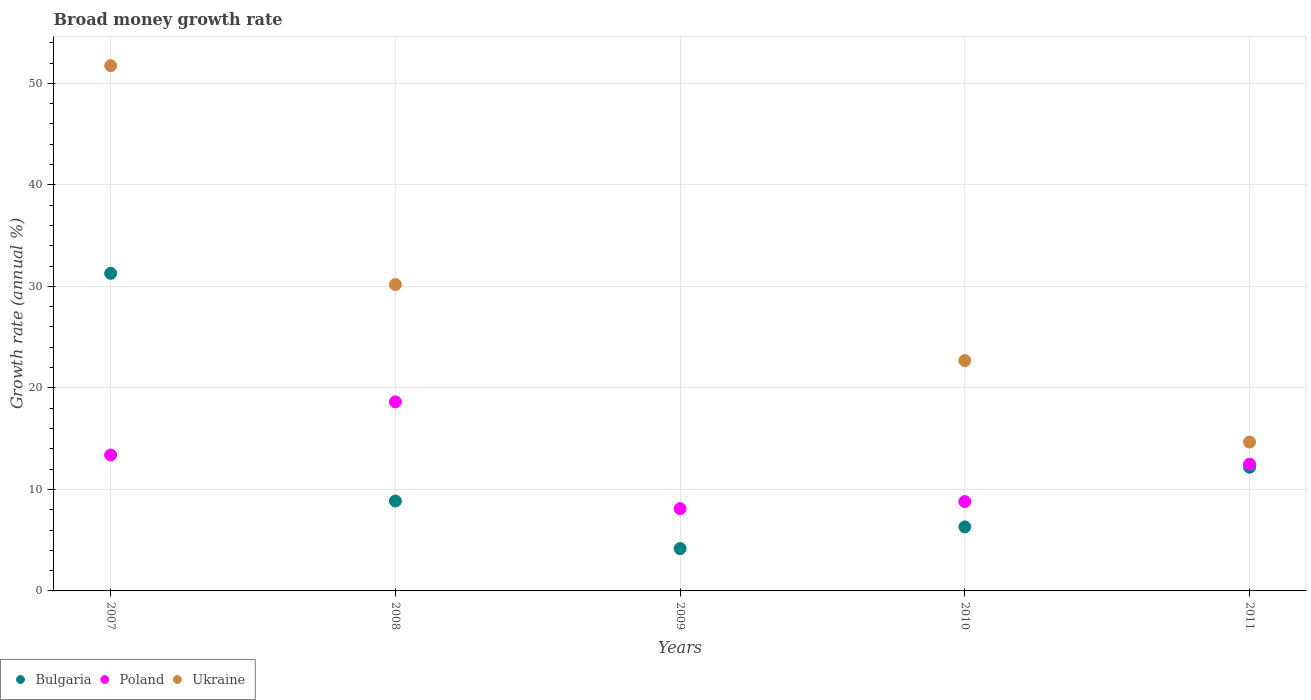How many different coloured dotlines are there?
Make the answer very short. 3. Is the number of dotlines equal to the number of legend labels?
Ensure brevity in your answer.  No. What is the growth rate in Ukraine in 2009?
Your response must be concise. 0. Across all years, what is the maximum growth rate in Bulgaria?
Offer a very short reply. 31.29. Across all years, what is the minimum growth rate in Ukraine?
Your answer should be compact. 0. What is the total growth rate in Bulgaria in the graph?
Your response must be concise. 62.8. What is the difference between the growth rate in Poland in 2009 and that in 2011?
Ensure brevity in your answer.  -4.38. What is the difference between the growth rate in Ukraine in 2010 and the growth rate in Poland in 2009?
Your response must be concise. 14.59. What is the average growth rate in Poland per year?
Provide a succinct answer. 12.28. In the year 2007, what is the difference between the growth rate in Ukraine and growth rate in Bulgaria?
Your answer should be very brief. 20.46. What is the ratio of the growth rate in Bulgaria in 2008 to that in 2009?
Provide a succinct answer. 2.12. What is the difference between the highest and the second highest growth rate in Ukraine?
Keep it short and to the point. 21.56. What is the difference between the highest and the lowest growth rate in Poland?
Give a very brief answer. 10.52. Is the sum of the growth rate in Poland in 2008 and 2011 greater than the maximum growth rate in Ukraine across all years?
Ensure brevity in your answer.  No. Is it the case that in every year, the sum of the growth rate in Poland and growth rate in Ukraine  is greater than the growth rate in Bulgaria?
Provide a short and direct response. Yes. Is the growth rate in Poland strictly less than the growth rate in Bulgaria over the years?
Provide a short and direct response. No. How many dotlines are there?
Offer a very short reply. 3. How many years are there in the graph?
Make the answer very short. 5. Does the graph contain any zero values?
Your response must be concise. Yes. Does the graph contain grids?
Offer a terse response. Yes. Where does the legend appear in the graph?
Offer a terse response. Bottom left. How many legend labels are there?
Your response must be concise. 3. What is the title of the graph?
Offer a very short reply. Broad money growth rate. Does "Benin" appear as one of the legend labels in the graph?
Ensure brevity in your answer.  No. What is the label or title of the X-axis?
Offer a very short reply. Years. What is the label or title of the Y-axis?
Provide a succinct answer. Growth rate (annual %). What is the Growth rate (annual %) of Bulgaria in 2007?
Offer a very short reply. 31.29. What is the Growth rate (annual %) in Poland in 2007?
Give a very brief answer. 13.39. What is the Growth rate (annual %) in Ukraine in 2007?
Offer a terse response. 51.75. What is the Growth rate (annual %) in Bulgaria in 2008?
Provide a short and direct response. 8.86. What is the Growth rate (annual %) in Poland in 2008?
Make the answer very short. 18.63. What is the Growth rate (annual %) in Ukraine in 2008?
Give a very brief answer. 30.18. What is the Growth rate (annual %) of Bulgaria in 2009?
Provide a succinct answer. 4.17. What is the Growth rate (annual %) in Poland in 2009?
Ensure brevity in your answer.  8.11. What is the Growth rate (annual %) in Ukraine in 2009?
Give a very brief answer. 0. What is the Growth rate (annual %) of Bulgaria in 2010?
Give a very brief answer. 6.3. What is the Growth rate (annual %) in Poland in 2010?
Give a very brief answer. 8.81. What is the Growth rate (annual %) of Ukraine in 2010?
Keep it short and to the point. 22.69. What is the Growth rate (annual %) in Bulgaria in 2011?
Offer a very short reply. 12.18. What is the Growth rate (annual %) of Poland in 2011?
Ensure brevity in your answer.  12.49. What is the Growth rate (annual %) of Ukraine in 2011?
Keep it short and to the point. 14.66. Across all years, what is the maximum Growth rate (annual %) in Bulgaria?
Offer a terse response. 31.29. Across all years, what is the maximum Growth rate (annual %) in Poland?
Make the answer very short. 18.63. Across all years, what is the maximum Growth rate (annual %) of Ukraine?
Offer a very short reply. 51.75. Across all years, what is the minimum Growth rate (annual %) in Bulgaria?
Give a very brief answer. 4.17. Across all years, what is the minimum Growth rate (annual %) in Poland?
Offer a terse response. 8.11. What is the total Growth rate (annual %) of Bulgaria in the graph?
Offer a very short reply. 62.8. What is the total Growth rate (annual %) of Poland in the graph?
Provide a succinct answer. 61.41. What is the total Growth rate (annual %) of Ukraine in the graph?
Your answer should be compact. 119.28. What is the difference between the Growth rate (annual %) in Bulgaria in 2007 and that in 2008?
Offer a very short reply. 22.43. What is the difference between the Growth rate (annual %) of Poland in 2007 and that in 2008?
Your answer should be compact. -5.24. What is the difference between the Growth rate (annual %) in Ukraine in 2007 and that in 2008?
Your answer should be very brief. 21.56. What is the difference between the Growth rate (annual %) of Bulgaria in 2007 and that in 2009?
Your answer should be compact. 27.11. What is the difference between the Growth rate (annual %) in Poland in 2007 and that in 2009?
Offer a very short reply. 5.28. What is the difference between the Growth rate (annual %) of Bulgaria in 2007 and that in 2010?
Offer a very short reply. 24.98. What is the difference between the Growth rate (annual %) in Poland in 2007 and that in 2010?
Make the answer very short. 4.58. What is the difference between the Growth rate (annual %) of Ukraine in 2007 and that in 2010?
Make the answer very short. 29.06. What is the difference between the Growth rate (annual %) of Bulgaria in 2007 and that in 2011?
Provide a succinct answer. 19.1. What is the difference between the Growth rate (annual %) of Poland in 2007 and that in 2011?
Give a very brief answer. 0.9. What is the difference between the Growth rate (annual %) in Ukraine in 2007 and that in 2011?
Offer a very short reply. 37.09. What is the difference between the Growth rate (annual %) in Bulgaria in 2008 and that in 2009?
Make the answer very short. 4.68. What is the difference between the Growth rate (annual %) of Poland in 2008 and that in 2009?
Provide a short and direct response. 10.52. What is the difference between the Growth rate (annual %) in Bulgaria in 2008 and that in 2010?
Provide a short and direct response. 2.55. What is the difference between the Growth rate (annual %) in Poland in 2008 and that in 2010?
Your response must be concise. 9.82. What is the difference between the Growth rate (annual %) in Ukraine in 2008 and that in 2010?
Keep it short and to the point. 7.49. What is the difference between the Growth rate (annual %) in Bulgaria in 2008 and that in 2011?
Your answer should be very brief. -3.32. What is the difference between the Growth rate (annual %) of Poland in 2008 and that in 2011?
Your response must be concise. 6.14. What is the difference between the Growth rate (annual %) in Ukraine in 2008 and that in 2011?
Give a very brief answer. 15.52. What is the difference between the Growth rate (annual %) of Bulgaria in 2009 and that in 2010?
Provide a short and direct response. -2.13. What is the difference between the Growth rate (annual %) in Poland in 2009 and that in 2010?
Your answer should be compact. -0.7. What is the difference between the Growth rate (annual %) of Bulgaria in 2009 and that in 2011?
Keep it short and to the point. -8.01. What is the difference between the Growth rate (annual %) of Poland in 2009 and that in 2011?
Your answer should be compact. -4.38. What is the difference between the Growth rate (annual %) of Bulgaria in 2010 and that in 2011?
Your answer should be very brief. -5.88. What is the difference between the Growth rate (annual %) of Poland in 2010 and that in 2011?
Keep it short and to the point. -3.68. What is the difference between the Growth rate (annual %) of Ukraine in 2010 and that in 2011?
Your answer should be very brief. 8.03. What is the difference between the Growth rate (annual %) in Bulgaria in 2007 and the Growth rate (annual %) in Poland in 2008?
Keep it short and to the point. 12.66. What is the difference between the Growth rate (annual %) of Bulgaria in 2007 and the Growth rate (annual %) of Ukraine in 2008?
Provide a short and direct response. 1.1. What is the difference between the Growth rate (annual %) of Poland in 2007 and the Growth rate (annual %) of Ukraine in 2008?
Your answer should be very brief. -16.79. What is the difference between the Growth rate (annual %) of Bulgaria in 2007 and the Growth rate (annual %) of Poland in 2009?
Provide a succinct answer. 23.18. What is the difference between the Growth rate (annual %) in Bulgaria in 2007 and the Growth rate (annual %) in Poland in 2010?
Your answer should be compact. 22.48. What is the difference between the Growth rate (annual %) of Bulgaria in 2007 and the Growth rate (annual %) of Ukraine in 2010?
Your response must be concise. 8.59. What is the difference between the Growth rate (annual %) of Poland in 2007 and the Growth rate (annual %) of Ukraine in 2010?
Provide a short and direct response. -9.3. What is the difference between the Growth rate (annual %) of Bulgaria in 2007 and the Growth rate (annual %) of Poland in 2011?
Provide a short and direct response. 18.8. What is the difference between the Growth rate (annual %) in Bulgaria in 2007 and the Growth rate (annual %) in Ukraine in 2011?
Your answer should be very brief. 16.63. What is the difference between the Growth rate (annual %) in Poland in 2007 and the Growth rate (annual %) in Ukraine in 2011?
Keep it short and to the point. -1.27. What is the difference between the Growth rate (annual %) in Bulgaria in 2008 and the Growth rate (annual %) in Poland in 2009?
Your answer should be very brief. 0.75. What is the difference between the Growth rate (annual %) in Bulgaria in 2008 and the Growth rate (annual %) in Poland in 2010?
Your answer should be compact. 0.05. What is the difference between the Growth rate (annual %) in Bulgaria in 2008 and the Growth rate (annual %) in Ukraine in 2010?
Your answer should be very brief. -13.83. What is the difference between the Growth rate (annual %) of Poland in 2008 and the Growth rate (annual %) of Ukraine in 2010?
Ensure brevity in your answer.  -4.07. What is the difference between the Growth rate (annual %) in Bulgaria in 2008 and the Growth rate (annual %) in Poland in 2011?
Provide a succinct answer. -3.63. What is the difference between the Growth rate (annual %) of Bulgaria in 2008 and the Growth rate (annual %) of Ukraine in 2011?
Give a very brief answer. -5.8. What is the difference between the Growth rate (annual %) of Poland in 2008 and the Growth rate (annual %) of Ukraine in 2011?
Ensure brevity in your answer.  3.97. What is the difference between the Growth rate (annual %) of Bulgaria in 2009 and the Growth rate (annual %) of Poland in 2010?
Your answer should be very brief. -4.63. What is the difference between the Growth rate (annual %) of Bulgaria in 2009 and the Growth rate (annual %) of Ukraine in 2010?
Keep it short and to the point. -18.52. What is the difference between the Growth rate (annual %) in Poland in 2009 and the Growth rate (annual %) in Ukraine in 2010?
Your answer should be compact. -14.59. What is the difference between the Growth rate (annual %) of Bulgaria in 2009 and the Growth rate (annual %) of Poland in 2011?
Offer a terse response. -8.31. What is the difference between the Growth rate (annual %) of Bulgaria in 2009 and the Growth rate (annual %) of Ukraine in 2011?
Give a very brief answer. -10.49. What is the difference between the Growth rate (annual %) in Poland in 2009 and the Growth rate (annual %) in Ukraine in 2011?
Offer a very short reply. -6.55. What is the difference between the Growth rate (annual %) in Bulgaria in 2010 and the Growth rate (annual %) in Poland in 2011?
Keep it short and to the point. -6.18. What is the difference between the Growth rate (annual %) in Bulgaria in 2010 and the Growth rate (annual %) in Ukraine in 2011?
Offer a very short reply. -8.35. What is the difference between the Growth rate (annual %) of Poland in 2010 and the Growth rate (annual %) of Ukraine in 2011?
Your response must be concise. -5.85. What is the average Growth rate (annual %) of Bulgaria per year?
Provide a succinct answer. 12.56. What is the average Growth rate (annual %) in Poland per year?
Keep it short and to the point. 12.28. What is the average Growth rate (annual %) in Ukraine per year?
Ensure brevity in your answer.  23.86. In the year 2007, what is the difference between the Growth rate (annual %) in Bulgaria and Growth rate (annual %) in Poland?
Make the answer very short. 17.9. In the year 2007, what is the difference between the Growth rate (annual %) of Bulgaria and Growth rate (annual %) of Ukraine?
Ensure brevity in your answer.  -20.46. In the year 2007, what is the difference between the Growth rate (annual %) in Poland and Growth rate (annual %) in Ukraine?
Ensure brevity in your answer.  -38.36. In the year 2008, what is the difference between the Growth rate (annual %) of Bulgaria and Growth rate (annual %) of Poland?
Offer a terse response. -9.77. In the year 2008, what is the difference between the Growth rate (annual %) in Bulgaria and Growth rate (annual %) in Ukraine?
Give a very brief answer. -21.33. In the year 2008, what is the difference between the Growth rate (annual %) of Poland and Growth rate (annual %) of Ukraine?
Ensure brevity in your answer.  -11.56. In the year 2009, what is the difference between the Growth rate (annual %) of Bulgaria and Growth rate (annual %) of Poland?
Ensure brevity in your answer.  -3.93. In the year 2010, what is the difference between the Growth rate (annual %) of Bulgaria and Growth rate (annual %) of Poland?
Keep it short and to the point. -2.5. In the year 2010, what is the difference between the Growth rate (annual %) of Bulgaria and Growth rate (annual %) of Ukraine?
Your response must be concise. -16.39. In the year 2010, what is the difference between the Growth rate (annual %) of Poland and Growth rate (annual %) of Ukraine?
Offer a very short reply. -13.89. In the year 2011, what is the difference between the Growth rate (annual %) of Bulgaria and Growth rate (annual %) of Poland?
Your answer should be compact. -0.31. In the year 2011, what is the difference between the Growth rate (annual %) of Bulgaria and Growth rate (annual %) of Ukraine?
Make the answer very short. -2.48. In the year 2011, what is the difference between the Growth rate (annual %) of Poland and Growth rate (annual %) of Ukraine?
Your answer should be very brief. -2.17. What is the ratio of the Growth rate (annual %) in Bulgaria in 2007 to that in 2008?
Provide a succinct answer. 3.53. What is the ratio of the Growth rate (annual %) in Poland in 2007 to that in 2008?
Offer a terse response. 0.72. What is the ratio of the Growth rate (annual %) in Ukraine in 2007 to that in 2008?
Provide a succinct answer. 1.71. What is the ratio of the Growth rate (annual %) in Bulgaria in 2007 to that in 2009?
Provide a short and direct response. 7.5. What is the ratio of the Growth rate (annual %) of Poland in 2007 to that in 2009?
Your answer should be very brief. 1.65. What is the ratio of the Growth rate (annual %) of Bulgaria in 2007 to that in 2010?
Provide a succinct answer. 4.96. What is the ratio of the Growth rate (annual %) in Poland in 2007 to that in 2010?
Provide a short and direct response. 1.52. What is the ratio of the Growth rate (annual %) of Ukraine in 2007 to that in 2010?
Your response must be concise. 2.28. What is the ratio of the Growth rate (annual %) of Bulgaria in 2007 to that in 2011?
Keep it short and to the point. 2.57. What is the ratio of the Growth rate (annual %) of Poland in 2007 to that in 2011?
Your answer should be very brief. 1.07. What is the ratio of the Growth rate (annual %) of Ukraine in 2007 to that in 2011?
Make the answer very short. 3.53. What is the ratio of the Growth rate (annual %) in Bulgaria in 2008 to that in 2009?
Your response must be concise. 2.12. What is the ratio of the Growth rate (annual %) in Poland in 2008 to that in 2009?
Provide a short and direct response. 2.3. What is the ratio of the Growth rate (annual %) in Bulgaria in 2008 to that in 2010?
Provide a succinct answer. 1.4. What is the ratio of the Growth rate (annual %) of Poland in 2008 to that in 2010?
Give a very brief answer. 2.12. What is the ratio of the Growth rate (annual %) in Ukraine in 2008 to that in 2010?
Provide a succinct answer. 1.33. What is the ratio of the Growth rate (annual %) in Bulgaria in 2008 to that in 2011?
Ensure brevity in your answer.  0.73. What is the ratio of the Growth rate (annual %) in Poland in 2008 to that in 2011?
Offer a very short reply. 1.49. What is the ratio of the Growth rate (annual %) in Ukraine in 2008 to that in 2011?
Give a very brief answer. 2.06. What is the ratio of the Growth rate (annual %) in Bulgaria in 2009 to that in 2010?
Your response must be concise. 0.66. What is the ratio of the Growth rate (annual %) in Poland in 2009 to that in 2010?
Provide a succinct answer. 0.92. What is the ratio of the Growth rate (annual %) of Bulgaria in 2009 to that in 2011?
Provide a short and direct response. 0.34. What is the ratio of the Growth rate (annual %) in Poland in 2009 to that in 2011?
Your answer should be compact. 0.65. What is the ratio of the Growth rate (annual %) in Bulgaria in 2010 to that in 2011?
Your answer should be very brief. 0.52. What is the ratio of the Growth rate (annual %) in Poland in 2010 to that in 2011?
Provide a short and direct response. 0.71. What is the ratio of the Growth rate (annual %) in Ukraine in 2010 to that in 2011?
Offer a very short reply. 1.55. What is the difference between the highest and the second highest Growth rate (annual %) of Bulgaria?
Ensure brevity in your answer.  19.1. What is the difference between the highest and the second highest Growth rate (annual %) of Poland?
Your answer should be very brief. 5.24. What is the difference between the highest and the second highest Growth rate (annual %) in Ukraine?
Ensure brevity in your answer.  21.56. What is the difference between the highest and the lowest Growth rate (annual %) of Bulgaria?
Ensure brevity in your answer.  27.11. What is the difference between the highest and the lowest Growth rate (annual %) in Poland?
Make the answer very short. 10.52. What is the difference between the highest and the lowest Growth rate (annual %) of Ukraine?
Make the answer very short. 51.75. 